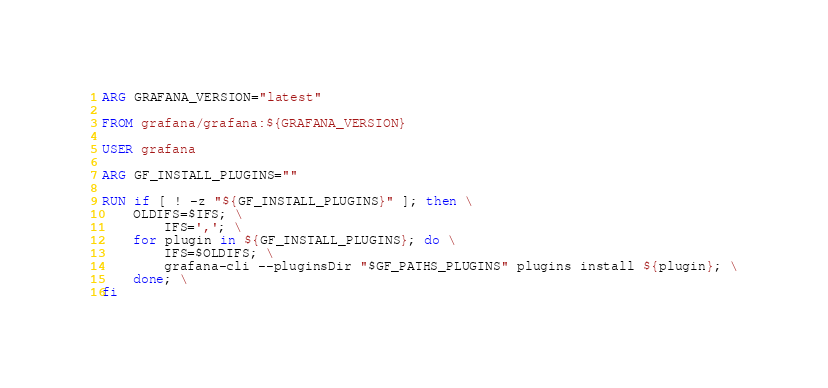<code> <loc_0><loc_0><loc_500><loc_500><_Dockerfile_>ARG GRAFANA_VERSION="latest"

FROM grafana/grafana:${GRAFANA_VERSION}

USER grafana

ARG GF_INSTALL_PLUGINS=""

RUN if [ ! -z "${GF_INSTALL_PLUGINS}" ]; then \
    OLDIFS=$IFS; \
        IFS=','; \
    for plugin in ${GF_INSTALL_PLUGINS}; do \
        IFS=$OLDIFS; \
        grafana-cli --pluginsDir "$GF_PATHS_PLUGINS" plugins install ${plugin}; \
    done; \
fi
</code> 